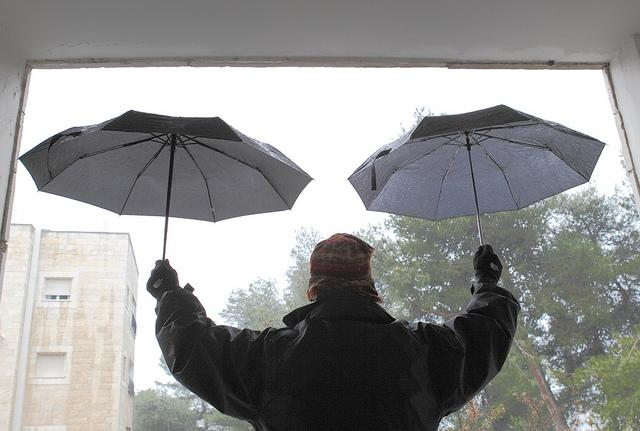What weather is being encountered here? rain 